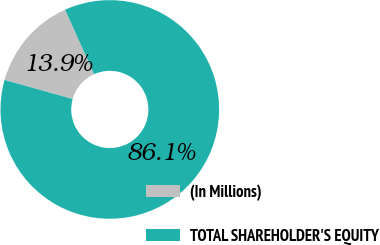Convert chart to OTSL. <chart><loc_0><loc_0><loc_500><loc_500><pie_chart><fcel>(In Millions)<fcel>TOTAL SHAREHOLDER'S EQUITY<nl><fcel>13.95%<fcel>86.05%<nl></chart> 